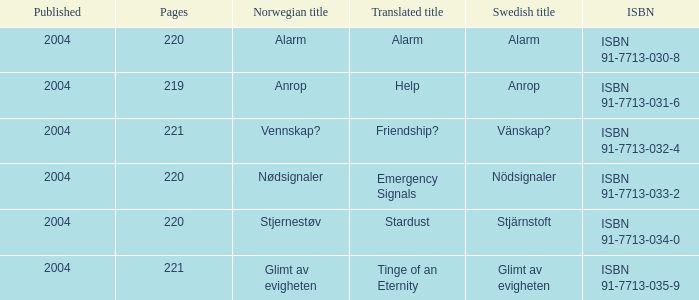How many pages associated with isbn 91-7713-035-9? 221.0. Parse the table in full. {'header': ['Published', 'Pages', 'Norwegian title', 'Translated title', 'Swedish title', 'ISBN'], 'rows': [['2004', '220', 'Alarm', 'Alarm', 'Alarm', 'ISBN 91-7713-030-8'], ['2004', '219', 'Anrop', 'Help', 'Anrop', 'ISBN 91-7713-031-6'], ['2004', '221', 'Vennskap?', 'Friendship?', 'Vänskap?', 'ISBN 91-7713-032-4'], ['2004', '220', 'Nødsignaler', 'Emergency Signals', 'Nödsignaler', 'ISBN 91-7713-033-2'], ['2004', '220', 'Stjernestøv', 'Stardust', 'Stjärnstoft', 'ISBN 91-7713-034-0'], ['2004', '221', 'Glimt av evigheten', 'Tinge of an Eternity', 'Glimt av evigheten', 'ISBN 91-7713-035-9']]} 